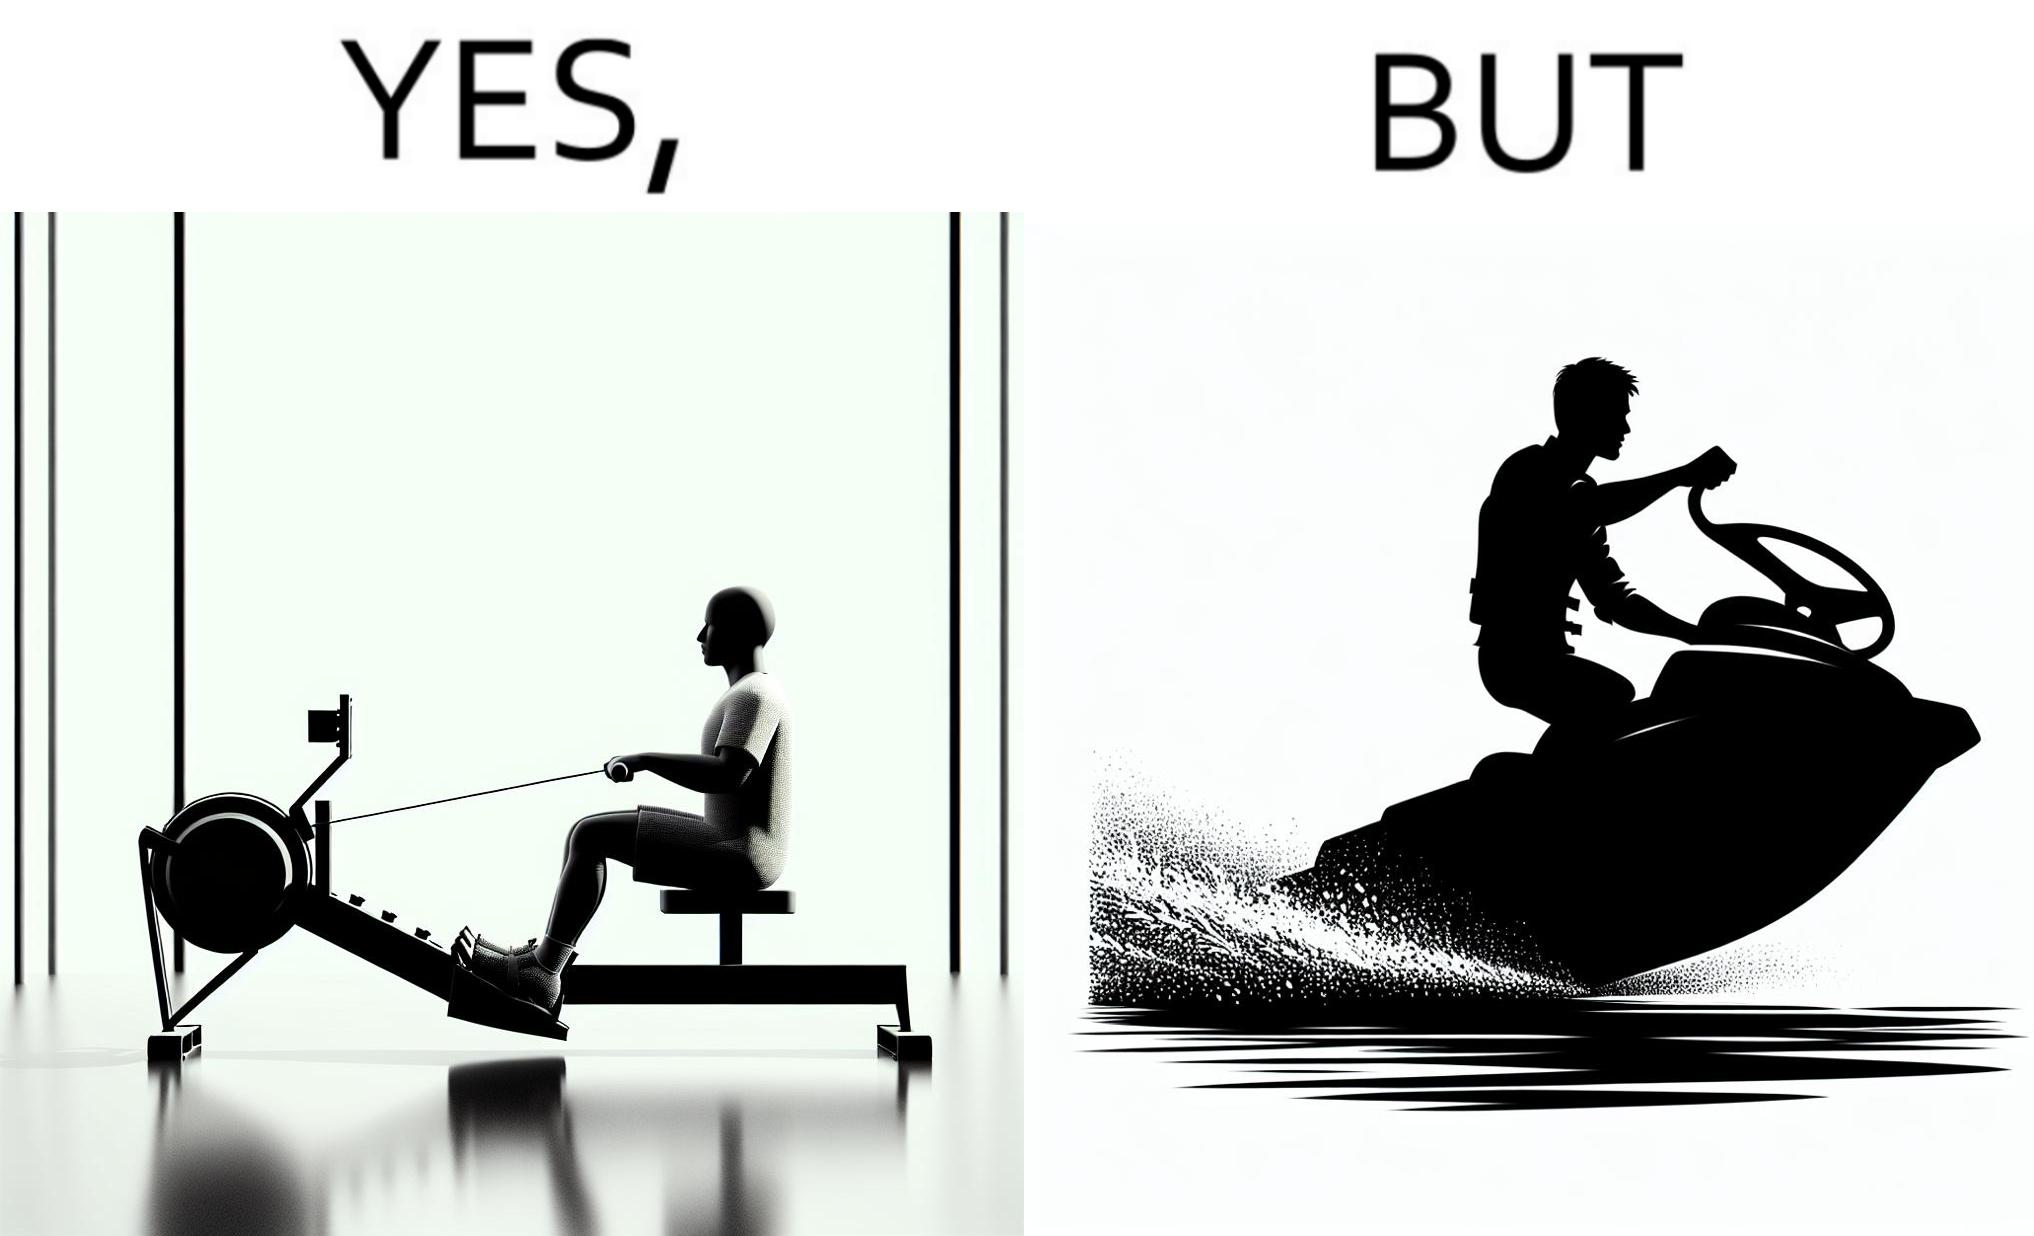Compare the left and right sides of this image. In the left part of the image: a person doing rowing exercise in gym In the right part of the image: a person riding a motorboat 